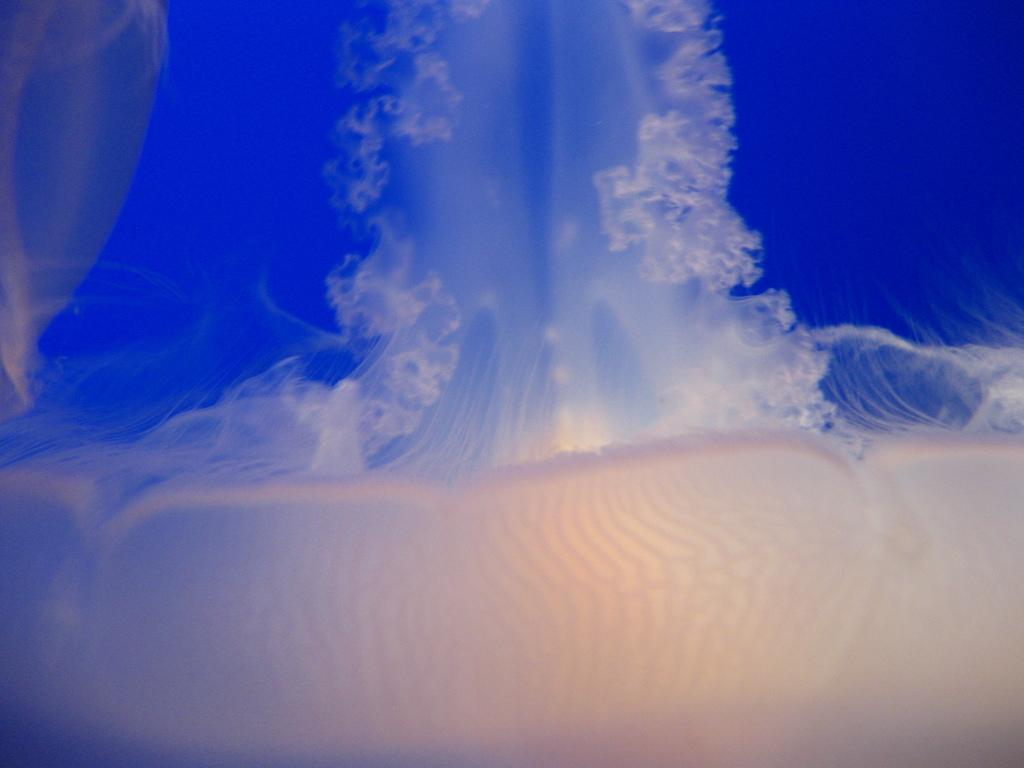What type of marine animals are in the image? There are jellyfish in the image. Where are the jellyfish located? The jellyfish are in the water. What type of pail can be seen being used to catch the jellyfish in the image? There is no pail present in the image, and the jellyfish are not being caught. How does the jellyfish push itself through the water in the image? Jellyfish do not push themselves through the water; they move by contracting and relaxing their muscles, which causes them to pulse and propel themselves forward. 